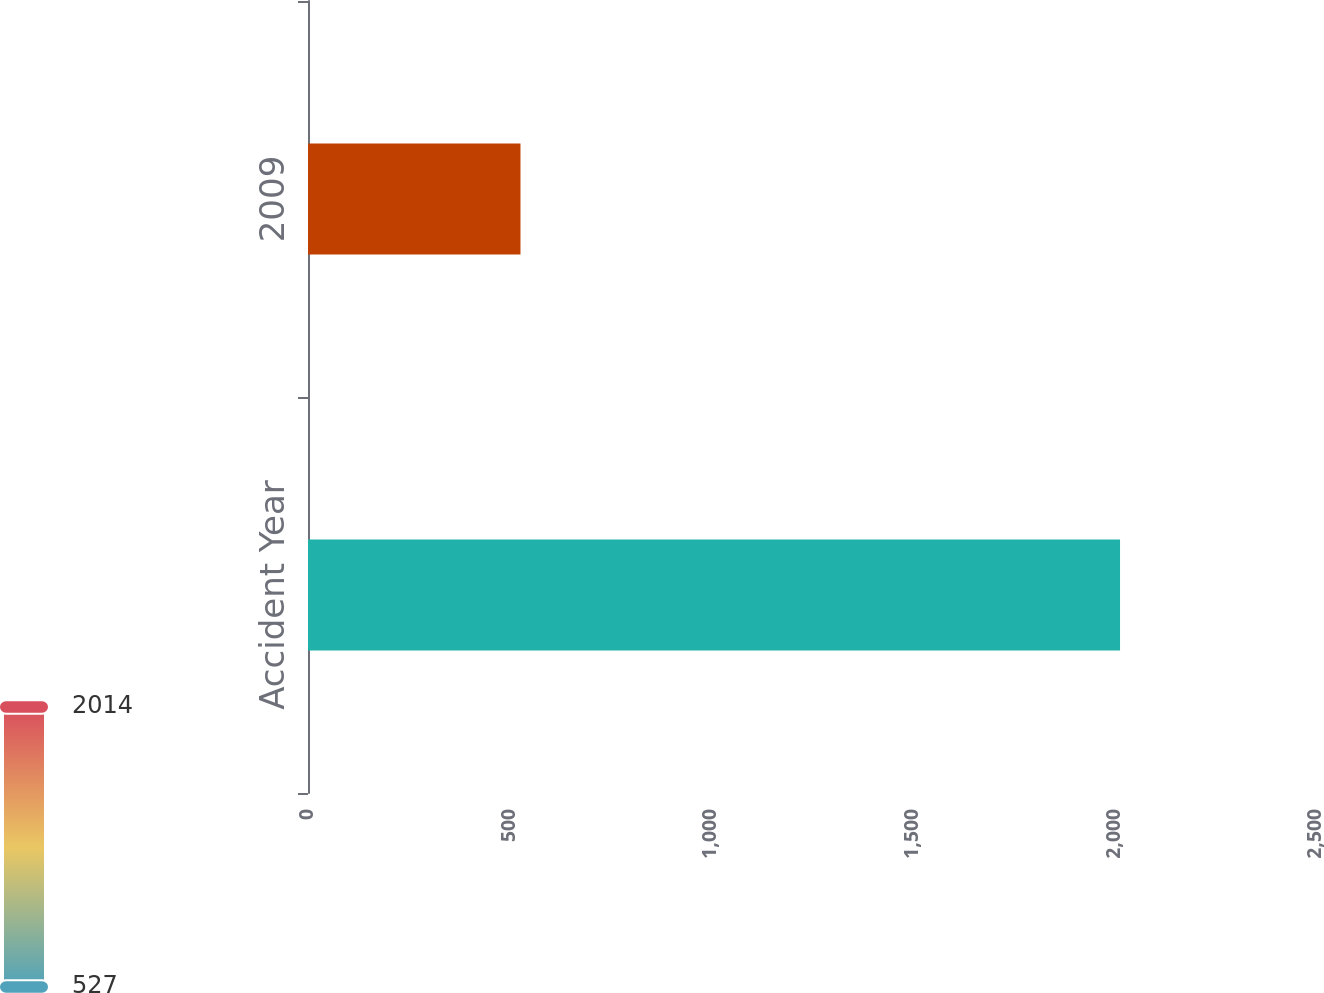<chart> <loc_0><loc_0><loc_500><loc_500><bar_chart><fcel>Accident Year<fcel>2009<nl><fcel>2014<fcel>527<nl></chart> 